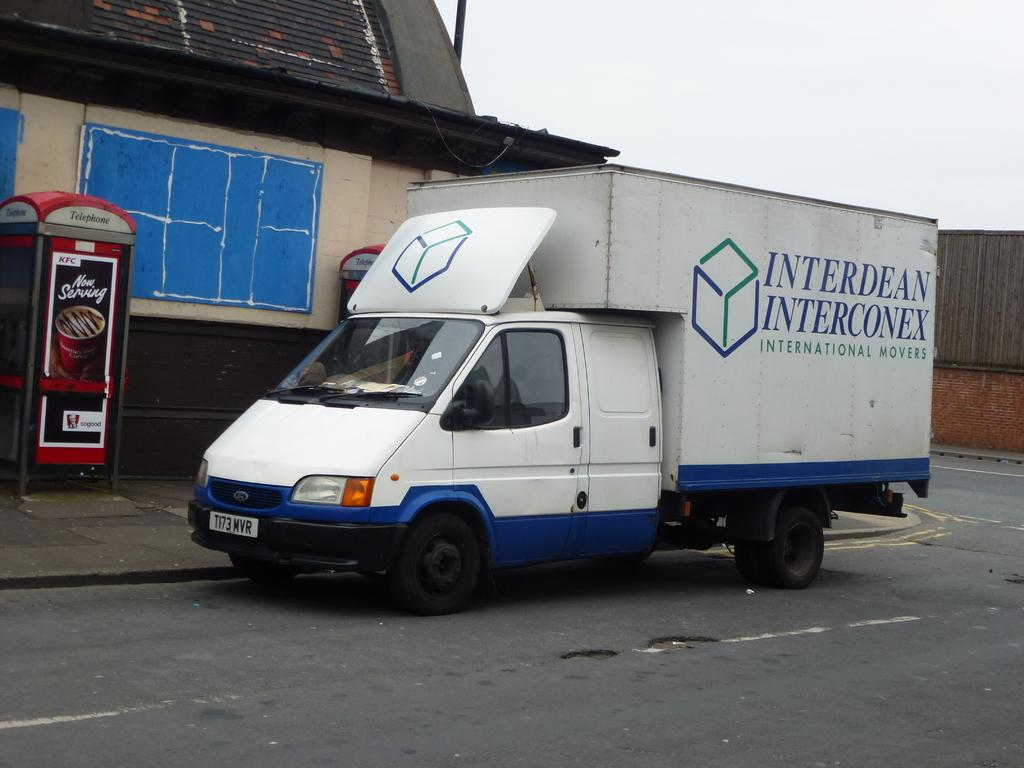What type of vehicle is on the road in the image? There is a motor vehicle on the road in the image. What structures are present in the image besides the motor vehicle? There are telephone booths and a shed in the image. What can be seen in the background of the image? The sky is visible in the background of the image. What type of cable is being used to provide heat in the image? There is no cable or heat source present in the image. 